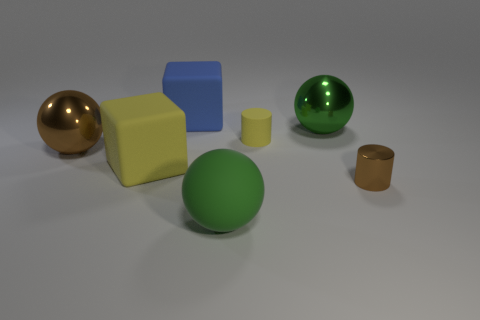Subtract all gray balls. Subtract all blue cylinders. How many balls are left? 3 Add 2 matte things. How many objects exist? 9 Subtract all cylinders. How many objects are left? 5 Add 6 brown metallic things. How many brown metallic things exist? 8 Subtract 0 red cylinders. How many objects are left? 7 Subtract all tiny brown shiny objects. Subtract all green shiny things. How many objects are left? 5 Add 2 big brown metal things. How many big brown metal things are left? 3 